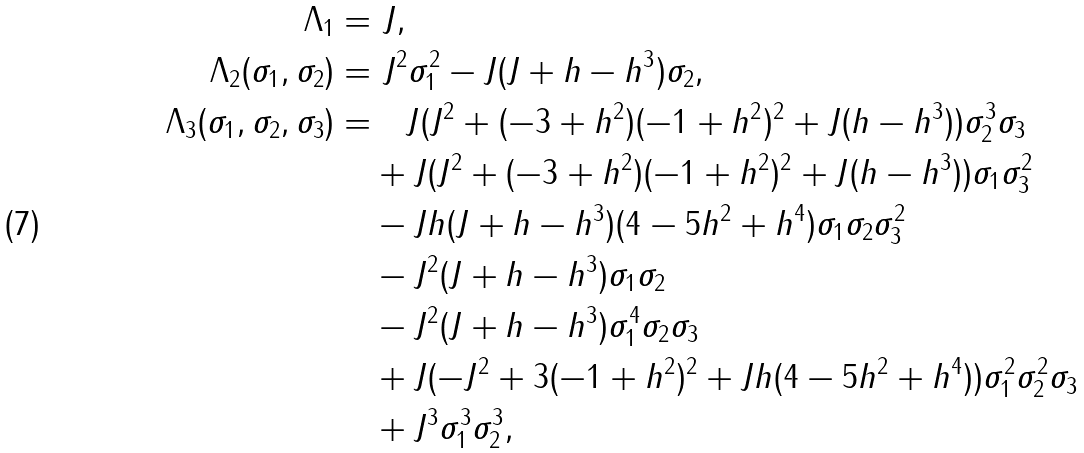<formula> <loc_0><loc_0><loc_500><loc_500>\Lambda _ { 1 } = & \ J , \\ \Lambda _ { 2 } ( \sigma _ { 1 } , \sigma _ { 2 } ) = & \ J ^ { 2 } \sigma _ { 1 } ^ { 2 } - J ( J + h - h ^ { 3 } ) \sigma _ { 2 } , \\ \Lambda _ { 3 } ( \sigma _ { 1 } , \sigma _ { 2 } , \sigma _ { 3 } ) = & \quad J ( J ^ { 2 } + ( - 3 + h ^ { 2 } ) ( - 1 + h ^ { 2 } ) ^ { 2 } + J ( h - h ^ { 3 } ) ) \sigma _ { 2 } ^ { 3 } \sigma _ { 3 } \\ & + J ( J ^ { 2 } + ( - 3 + h ^ { 2 } ) ( - 1 + h ^ { 2 } ) ^ { 2 } + J ( h - h ^ { 3 } ) ) \sigma _ { 1 } \sigma _ { 3 } ^ { 2 } \\ & - J h ( J + h - h ^ { 3 } ) ( 4 - 5 h ^ { 2 } + h ^ { 4 } ) \sigma _ { 1 } \sigma _ { 2 } \sigma _ { 3 } ^ { 2 } \\ & - J ^ { 2 } ( J + h - h ^ { 3 } ) \sigma _ { 1 } \sigma _ { 2 } \\ & - J ^ { 2 } ( J + h - h ^ { 3 } ) \sigma _ { 1 } ^ { 4 } \sigma _ { 2 } \sigma _ { 3 } \\ & + J ( - J ^ { 2 } + 3 ( - 1 + h ^ { 2 } ) ^ { 2 } + J h ( 4 - 5 h ^ { 2 } + h ^ { 4 } ) ) \sigma _ { 1 } ^ { 2 } \sigma _ { 2 } ^ { 2 } \sigma _ { 3 } \\ & + J ^ { 3 } \sigma _ { 1 } ^ { 3 } \sigma _ { 2 } ^ { 3 } ,</formula> 